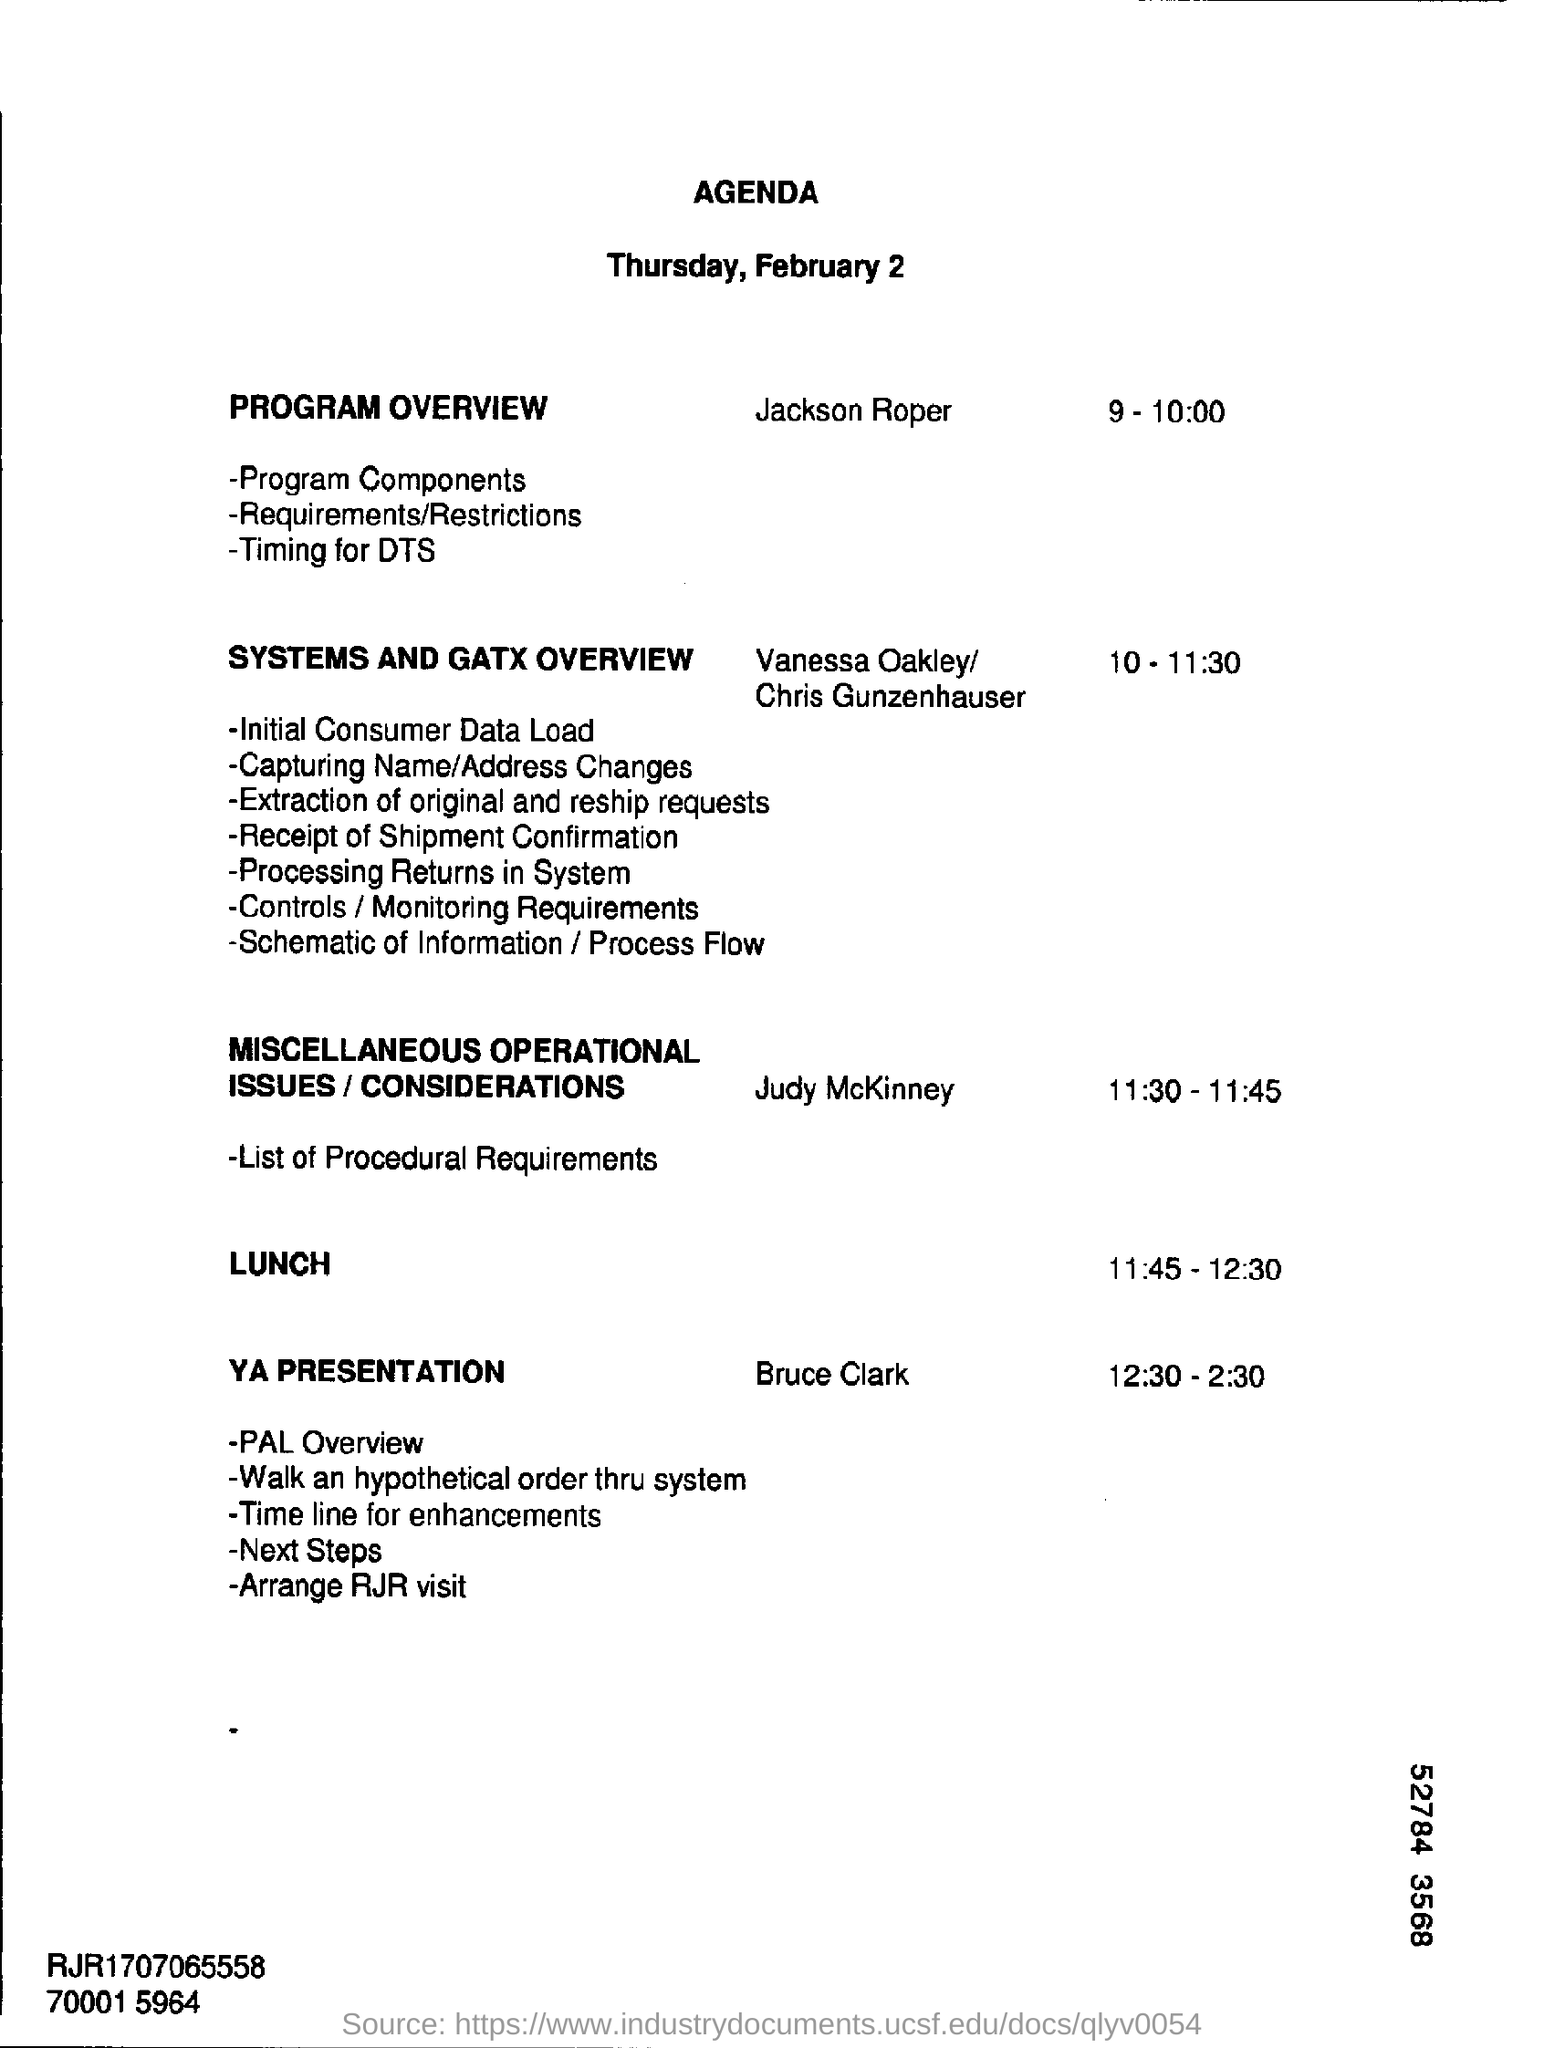Who will do the program overview?
Ensure brevity in your answer.  Jackson Roper. 